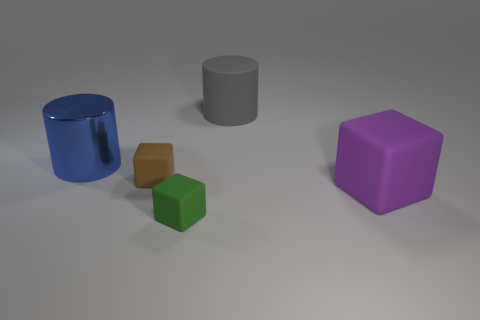Subtract all tiny blocks. How many blocks are left? 1 Add 1 large rubber balls. How many objects exist? 6 Subtract 1 blocks. How many blocks are left? 2 Subtract all brown cubes. How many cubes are left? 2 Subtract all yellow blocks. Subtract all blue cylinders. How many blocks are left? 3 Add 3 rubber blocks. How many rubber blocks are left? 6 Add 5 tiny cyan objects. How many tiny cyan objects exist? 5 Subtract 0 yellow spheres. How many objects are left? 5 Subtract all cylinders. How many objects are left? 3 Subtract all large purple cubes. Subtract all large gray blocks. How many objects are left? 4 